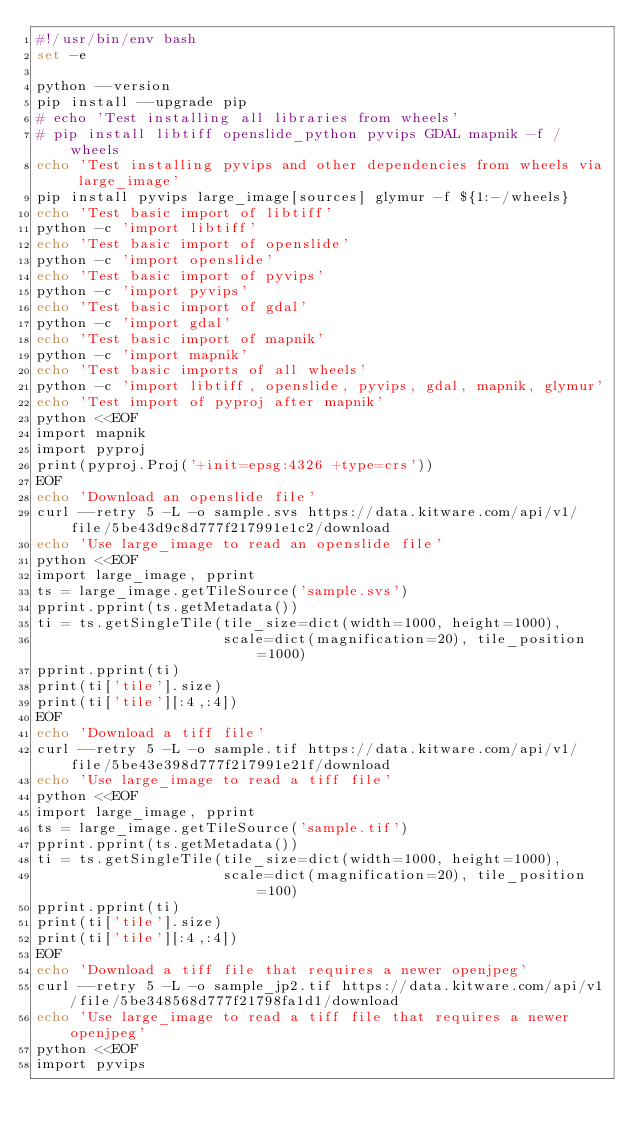Convert code to text. <code><loc_0><loc_0><loc_500><loc_500><_Bash_>#!/usr/bin/env bash
set -e

python --version
pip install --upgrade pip
# echo 'Test installing all libraries from wheels'
# pip install libtiff openslide_python pyvips GDAL mapnik -f /wheels
echo 'Test installing pyvips and other dependencies from wheels via large_image'
pip install pyvips large_image[sources] glymur -f ${1:-/wheels}
echo 'Test basic import of libtiff'
python -c 'import libtiff'
echo 'Test basic import of openslide'
python -c 'import openslide'
echo 'Test basic import of pyvips'
python -c 'import pyvips'
echo 'Test basic import of gdal'
python -c 'import gdal'
echo 'Test basic import of mapnik'
python -c 'import mapnik'
echo 'Test basic imports of all wheels'
python -c 'import libtiff, openslide, pyvips, gdal, mapnik, glymur'
echo 'Test import of pyproj after mapnik'
python <<EOF
import mapnik
import pyproj
print(pyproj.Proj('+init=epsg:4326 +type=crs'))
EOF
echo 'Download an openslide file'
curl --retry 5 -L -o sample.svs https://data.kitware.com/api/v1/file/5be43d9c8d777f217991e1c2/download
echo 'Use large_image to read an openslide file'
python <<EOF
import large_image, pprint
ts = large_image.getTileSource('sample.svs')
pprint.pprint(ts.getMetadata())
ti = ts.getSingleTile(tile_size=dict(width=1000, height=1000),
                      scale=dict(magnification=20), tile_position=1000)
pprint.pprint(ti)
print(ti['tile'].size)
print(ti['tile'][:4,:4])
EOF
echo 'Download a tiff file'
curl --retry 5 -L -o sample.tif https://data.kitware.com/api/v1/file/5be43e398d777f217991e21f/download
echo 'Use large_image to read a tiff file'
python <<EOF
import large_image, pprint
ts = large_image.getTileSource('sample.tif')
pprint.pprint(ts.getMetadata())
ti = ts.getSingleTile(tile_size=dict(width=1000, height=1000),
                      scale=dict(magnification=20), tile_position=100)
pprint.pprint(ti)
print(ti['tile'].size)
print(ti['tile'][:4,:4])
EOF
echo 'Download a tiff file that requires a newer openjpeg'
curl --retry 5 -L -o sample_jp2.tif https://data.kitware.com/api/v1/file/5be348568d777f21798fa1d1/download
echo 'Use large_image to read a tiff file that requires a newer openjpeg'
python <<EOF
import pyvips</code> 